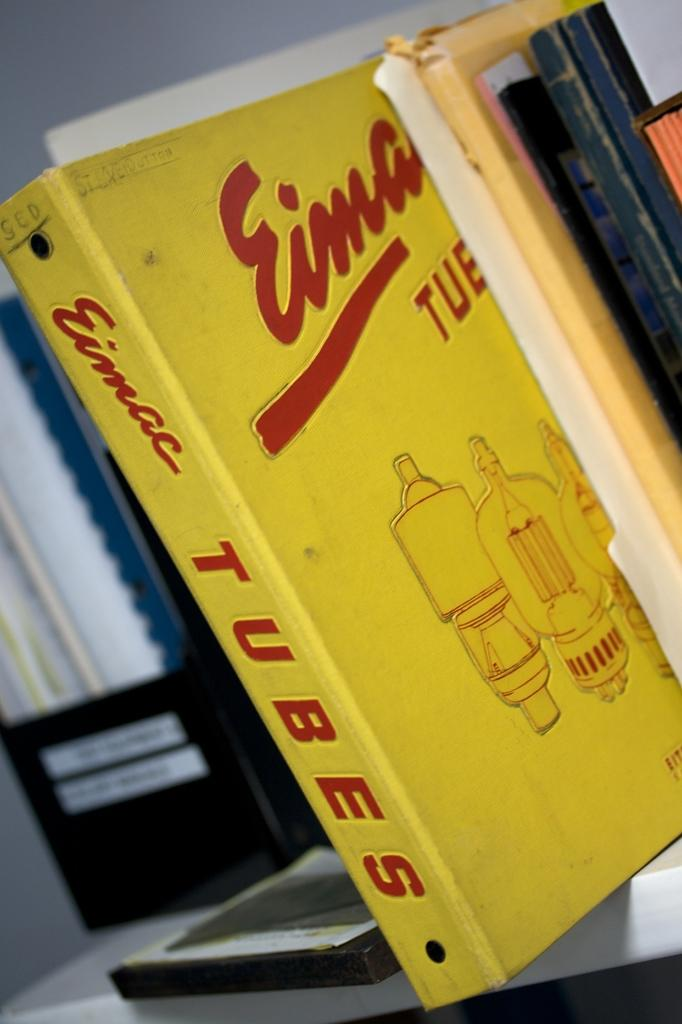<image>
Create a compact narrative representing the image presented. A binder with information about Eimac tubes sits on a shelf. 